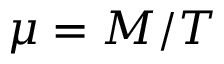Convert formula to latex. <formula><loc_0><loc_0><loc_500><loc_500>\mu = M / T</formula> 